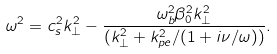Convert formula to latex. <formula><loc_0><loc_0><loc_500><loc_500>\omega ^ { 2 } = c _ { s } ^ { 2 } k _ { \perp } ^ { 2 } - \frac { \omega _ { b } ^ { 2 } \beta _ { 0 } ^ { 2 } k _ { \perp } ^ { 2 } } { ( k _ { \perp } ^ { 2 } + k _ { p e } ^ { 2 } / ( 1 + i \nu / \omega ) ) } .</formula> 